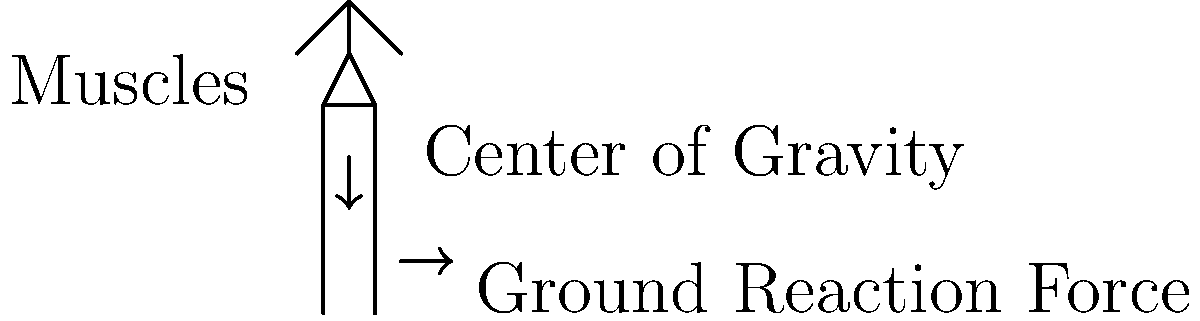As a nurse who understands the importance of proper posture, explain the biomechanical principles involved in maintaining an upright standing position for extended periods. How do these principles relate to the prevention of musculoskeletal disorders in healthcare professionals? To maintain proper posture while standing for long periods, several biomechanical principles are at play:

1. Center of Gravity (CoG): The body's CoG is typically located just anterior to the second sacral vertebra. In proper standing posture, the CoG should be aligned vertically with the base of support.

2. Base of Support: This is the area between the feet. A wider stance increases stability but requires more muscle engagement to maintain.

3. Line of Gravity: An imaginary vertical line passing through the CoG. Proper alignment means this line should pass through key joints: ear, shoulder, hip, knee, and ankle.

4. Ground Reaction Force: Equal and opposite to the force exerted by the body on the ground. In proper posture, this force should be balanced with the body's weight.

5. Muscle Activity: Postural muscles work isometrically to maintain the upright position. Key muscle groups include:
   - Erector spinae: Keeps the trunk upright
   - Abdominals: Provides anterior support
   - Gluteus medius and minimus: Stabilize the pelvis

6. Joint Moments: Minimal joint moments are created when the line of gravity passes close to joint centers. This reduces muscle strain and energy expenditure.

7. Energy Conservation: Proper alignment minimizes the need for active muscle contraction, conserving energy over long periods.

To prevent musculoskeletal disorders:
- Maintain neutral spine posture to reduce intervertebral disc pressure
- Avoid prolonged static postures by shifting weight periodically
- Use anti-fatigue mats to reduce lower limb and back strain
- Wear supportive footwear to maintain proper foot alignment
- Engage in regular stretching and strengthening exercises to support postural muscles

By understanding and applying these principles, healthcare professionals can significantly reduce their risk of developing work-related musculoskeletal disorders associated with prolonged standing.
Answer: Vertical alignment of CoG with base of support, balanced muscle activity, and minimal joint moments for energy conservation 